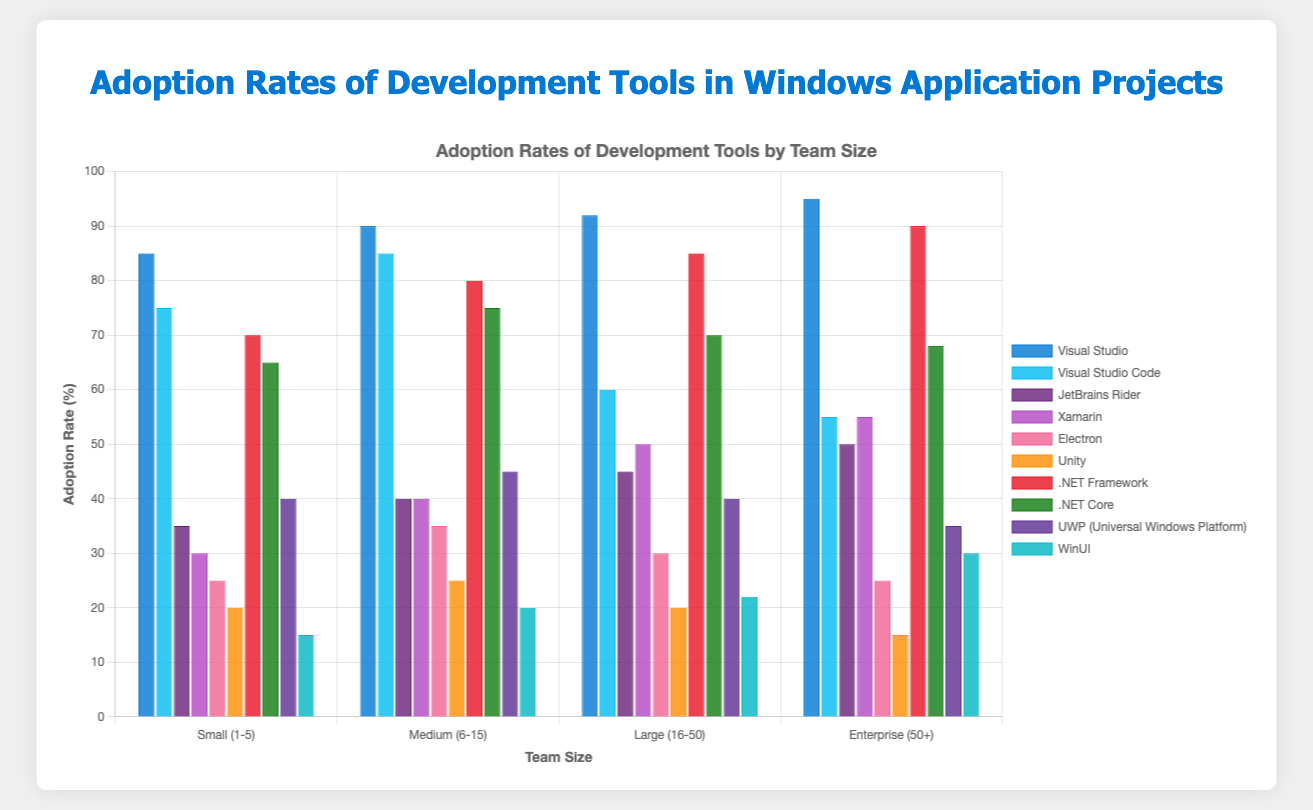What's the adoption rate of Visual Studio in medium-sized teams? The adoption rate for Visual Studio in medium-sized teams (6-15 members) is directly shown as a bar on the figure labeled about 90.
Answer: 90 Which tool has the least adoption rate in enterprise teams? Inspecting the bars for enterprise teams (50+) across all tools, the lowest bar corresponds to Unity with an adoption rate of 15%.
Answer: Unity What's the difference in adoption rates between Visual Studio and JetBrains Rider for small teams? The adoption rates for Visual Studio and JetBrains Rider in small teams (1-5 members) are 85 and 35 respectively. The difference is thus 85 - 35 = 50%.
Answer: 50 Which tool shows the highest increase in adoption rate as the team size increases? By inspecting all bars for the tools across different team sizes, Visual Studio consistently increases its adoption rate from 85 in small teams to 95 in enterprise teams, representing a 10-point increase.
Answer: Visual Studio What's the average adoption rate of .NET Framework across all team sizes? The adoption rates for .NET Framework are 70, 80, 85, and 90 for the different team sizes. The average is calculated as (70 + 80 + 85 + 90) / 4 = 81.25.
Answer: 81.25 Which development tool exhibits a decline in its adoption rate as team size increases? By inspecting the visual trends in the bars, Visual Studio Code's adoption rates decrease as team size grows, marked by 75, 85, 60, and 55 from small to enterprise teams.
Answer: Visual Studio Code How does the adoption rate of Xamarin compare to JetBrains Rider in large teams? In large teams (16-50), Xamarin has an adoption rate of 50% while JetBrains Rider has 45%. Therefore, Xamarin has a higher adoption rate than JetBrains Rider.
Answer: Xamarin, higher What tool has the highest adoption rate for small teams? Observing the bars for small teams (1-5), Visual Studio has the highest bar with an 85% adoption rate.
Answer: Visual Studio What's the summed adoption rate of UWP and Unity in medium-sized teams? For medium-sized teams (6-15), the adoption rates for UWP and Unity are 45 and 25 respectively. The sum is 45 + 25 = 70%.
Answer: 70 